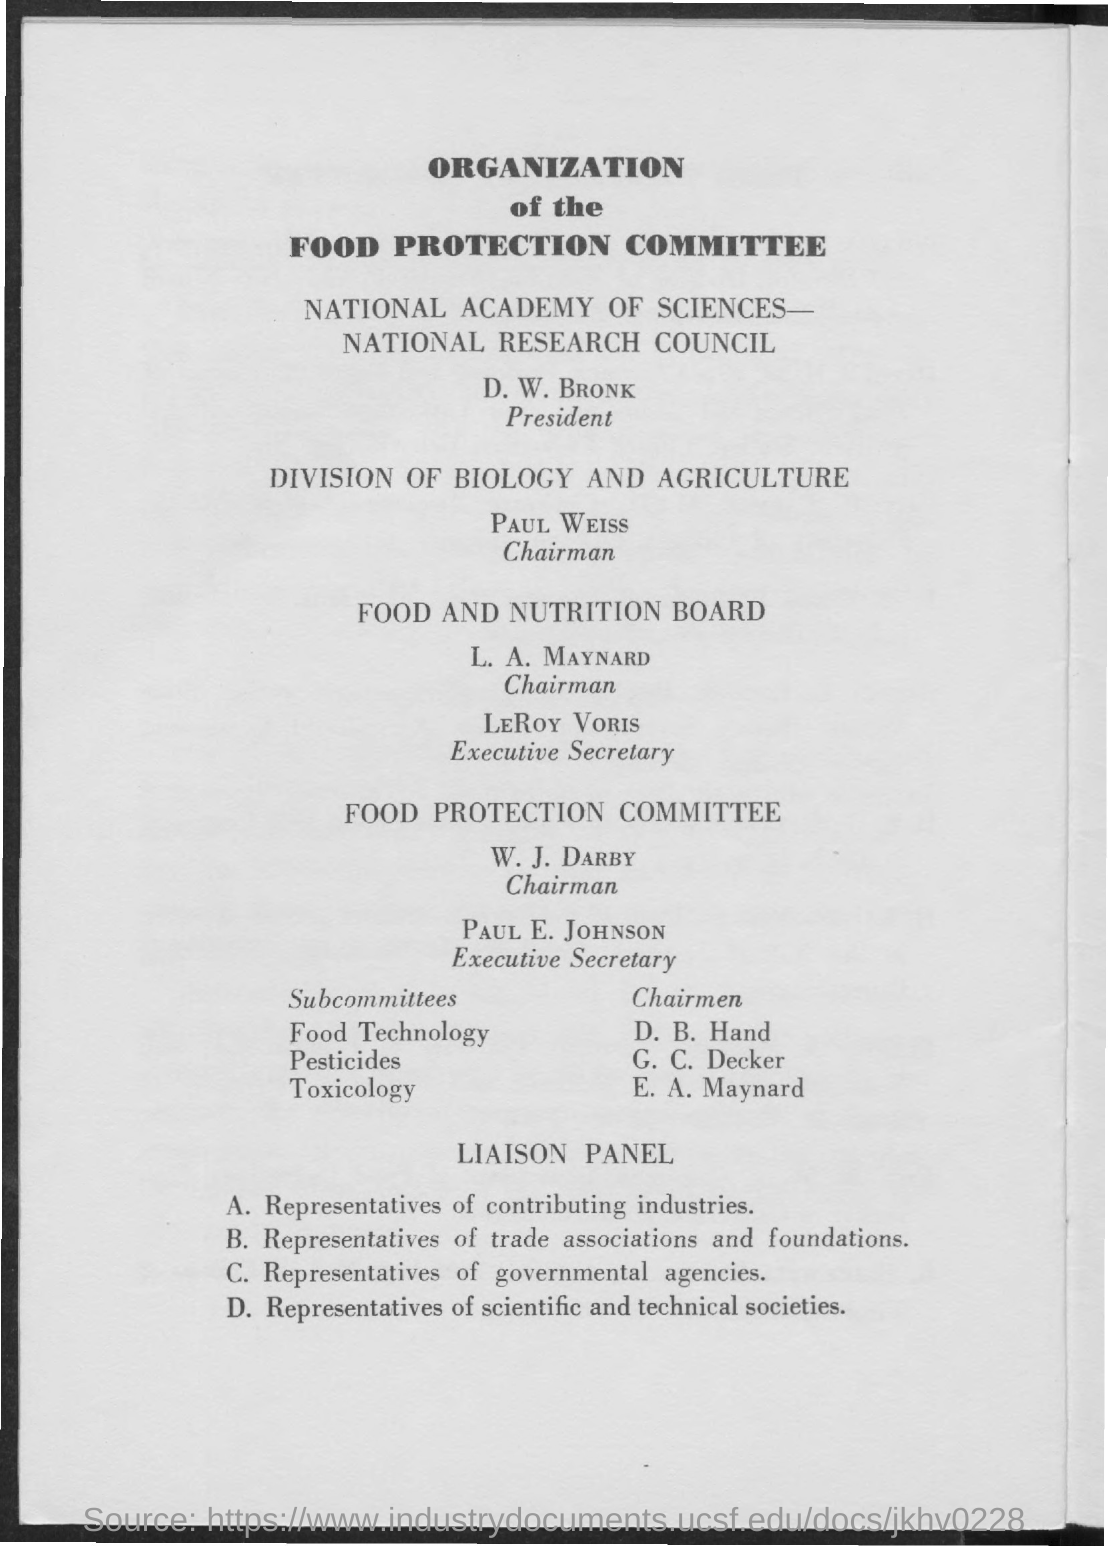Who is the Chairman of Food and Nutrition Board?
Offer a very short reply. L. A. Maynard. Who is the Executive secretary of Food and Nutrition Board?
Your answer should be compact. LeRoy Voris. Who is the Executive Secretary of Food Protection Committee?
Make the answer very short. Paul E. Johnson. 